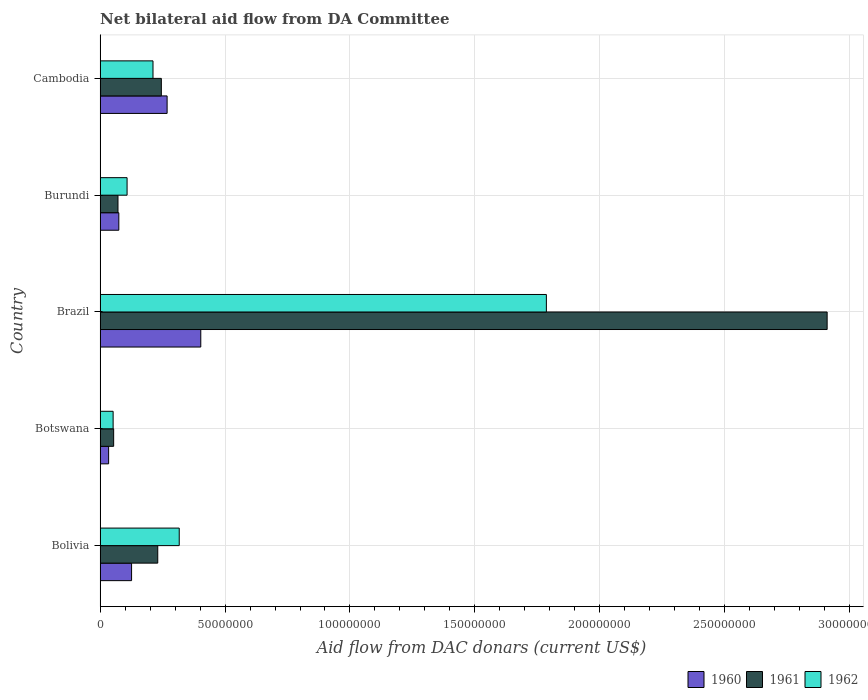How many different coloured bars are there?
Your response must be concise. 3. How many groups of bars are there?
Make the answer very short. 5. Are the number of bars per tick equal to the number of legend labels?
Keep it short and to the point. Yes. How many bars are there on the 4th tick from the top?
Offer a very short reply. 3. How many bars are there on the 5th tick from the bottom?
Your answer should be compact. 3. What is the aid flow in in 1962 in Botswana?
Ensure brevity in your answer.  5.23e+06. Across all countries, what is the maximum aid flow in in 1960?
Your answer should be compact. 4.03e+07. Across all countries, what is the minimum aid flow in in 1962?
Offer a terse response. 5.23e+06. In which country was the aid flow in in 1961 maximum?
Offer a very short reply. Brazil. In which country was the aid flow in in 1961 minimum?
Give a very brief answer. Botswana. What is the total aid flow in in 1962 in the graph?
Offer a terse response. 2.47e+08. What is the difference between the aid flow in in 1962 in Bolivia and that in Cambodia?
Offer a very short reply. 1.05e+07. What is the difference between the aid flow in in 1960 in Bolivia and the aid flow in in 1962 in Cambodia?
Your answer should be very brief. -8.57e+06. What is the average aid flow in in 1960 per country?
Give a very brief answer. 1.81e+07. What is the difference between the aid flow in in 1962 and aid flow in in 1960 in Botswana?
Provide a succinct answer. 1.80e+06. In how many countries, is the aid flow in in 1961 greater than 50000000 US$?
Keep it short and to the point. 1. What is the ratio of the aid flow in in 1961 in Bolivia to that in Cambodia?
Offer a very short reply. 0.94. Is the aid flow in in 1962 in Botswana less than that in Brazil?
Ensure brevity in your answer.  Yes. Is the difference between the aid flow in in 1962 in Botswana and Cambodia greater than the difference between the aid flow in in 1960 in Botswana and Cambodia?
Offer a terse response. Yes. What is the difference between the highest and the second highest aid flow in in 1961?
Your answer should be very brief. 2.66e+08. What is the difference between the highest and the lowest aid flow in in 1960?
Provide a succinct answer. 3.69e+07. In how many countries, is the aid flow in in 1962 greater than the average aid flow in in 1962 taken over all countries?
Your answer should be very brief. 1. How many bars are there?
Your response must be concise. 15. Are all the bars in the graph horizontal?
Offer a very short reply. Yes. How many countries are there in the graph?
Your answer should be very brief. 5. Are the values on the major ticks of X-axis written in scientific E-notation?
Provide a short and direct response. No. Does the graph contain any zero values?
Your answer should be very brief. No. How many legend labels are there?
Provide a succinct answer. 3. What is the title of the graph?
Give a very brief answer. Net bilateral aid flow from DA Committee. What is the label or title of the X-axis?
Provide a succinct answer. Aid flow from DAC donars (current US$). What is the Aid flow from DAC donars (current US$) in 1960 in Bolivia?
Your answer should be very brief. 1.26e+07. What is the Aid flow from DAC donars (current US$) of 1961 in Bolivia?
Give a very brief answer. 2.31e+07. What is the Aid flow from DAC donars (current US$) of 1962 in Bolivia?
Provide a succinct answer. 3.17e+07. What is the Aid flow from DAC donars (current US$) in 1960 in Botswana?
Ensure brevity in your answer.  3.43e+06. What is the Aid flow from DAC donars (current US$) of 1961 in Botswana?
Make the answer very short. 5.44e+06. What is the Aid flow from DAC donars (current US$) of 1962 in Botswana?
Your answer should be compact. 5.23e+06. What is the Aid flow from DAC donars (current US$) of 1960 in Brazil?
Offer a very short reply. 4.03e+07. What is the Aid flow from DAC donars (current US$) in 1961 in Brazil?
Offer a terse response. 2.91e+08. What is the Aid flow from DAC donars (current US$) of 1962 in Brazil?
Your response must be concise. 1.79e+08. What is the Aid flow from DAC donars (current US$) in 1960 in Burundi?
Make the answer very short. 7.51e+06. What is the Aid flow from DAC donars (current US$) of 1961 in Burundi?
Ensure brevity in your answer.  7.17e+06. What is the Aid flow from DAC donars (current US$) of 1962 in Burundi?
Your answer should be very brief. 1.08e+07. What is the Aid flow from DAC donars (current US$) in 1960 in Cambodia?
Give a very brief answer. 2.68e+07. What is the Aid flow from DAC donars (current US$) in 1961 in Cambodia?
Offer a terse response. 2.45e+07. What is the Aid flow from DAC donars (current US$) of 1962 in Cambodia?
Give a very brief answer. 2.12e+07. Across all countries, what is the maximum Aid flow from DAC donars (current US$) in 1960?
Give a very brief answer. 4.03e+07. Across all countries, what is the maximum Aid flow from DAC donars (current US$) in 1961?
Ensure brevity in your answer.  2.91e+08. Across all countries, what is the maximum Aid flow from DAC donars (current US$) of 1962?
Offer a terse response. 1.79e+08. Across all countries, what is the minimum Aid flow from DAC donars (current US$) of 1960?
Your answer should be very brief. 3.43e+06. Across all countries, what is the minimum Aid flow from DAC donars (current US$) in 1961?
Provide a succinct answer. 5.44e+06. Across all countries, what is the minimum Aid flow from DAC donars (current US$) in 1962?
Your answer should be compact. 5.23e+06. What is the total Aid flow from DAC donars (current US$) of 1960 in the graph?
Ensure brevity in your answer.  9.07e+07. What is the total Aid flow from DAC donars (current US$) in 1961 in the graph?
Provide a succinct answer. 3.51e+08. What is the total Aid flow from DAC donars (current US$) of 1962 in the graph?
Provide a succinct answer. 2.47e+08. What is the difference between the Aid flow from DAC donars (current US$) in 1960 in Bolivia and that in Botswana?
Ensure brevity in your answer.  9.18e+06. What is the difference between the Aid flow from DAC donars (current US$) of 1961 in Bolivia and that in Botswana?
Make the answer very short. 1.76e+07. What is the difference between the Aid flow from DAC donars (current US$) in 1962 in Bolivia and that in Botswana?
Offer a very short reply. 2.64e+07. What is the difference between the Aid flow from DAC donars (current US$) of 1960 in Bolivia and that in Brazil?
Give a very brief answer. -2.77e+07. What is the difference between the Aid flow from DAC donars (current US$) in 1961 in Bolivia and that in Brazil?
Provide a succinct answer. -2.68e+08. What is the difference between the Aid flow from DAC donars (current US$) in 1962 in Bolivia and that in Brazil?
Offer a very short reply. -1.47e+08. What is the difference between the Aid flow from DAC donars (current US$) in 1960 in Bolivia and that in Burundi?
Keep it short and to the point. 5.10e+06. What is the difference between the Aid flow from DAC donars (current US$) of 1961 in Bolivia and that in Burundi?
Offer a very short reply. 1.59e+07. What is the difference between the Aid flow from DAC donars (current US$) of 1962 in Bolivia and that in Burundi?
Your answer should be compact. 2.09e+07. What is the difference between the Aid flow from DAC donars (current US$) in 1960 in Bolivia and that in Cambodia?
Your response must be concise. -1.42e+07. What is the difference between the Aid flow from DAC donars (current US$) of 1961 in Bolivia and that in Cambodia?
Keep it short and to the point. -1.44e+06. What is the difference between the Aid flow from DAC donars (current US$) in 1962 in Bolivia and that in Cambodia?
Keep it short and to the point. 1.05e+07. What is the difference between the Aid flow from DAC donars (current US$) in 1960 in Botswana and that in Brazil?
Your answer should be very brief. -3.69e+07. What is the difference between the Aid flow from DAC donars (current US$) of 1961 in Botswana and that in Brazil?
Offer a terse response. -2.85e+08. What is the difference between the Aid flow from DAC donars (current US$) of 1962 in Botswana and that in Brazil?
Offer a very short reply. -1.73e+08. What is the difference between the Aid flow from DAC donars (current US$) in 1960 in Botswana and that in Burundi?
Make the answer very short. -4.08e+06. What is the difference between the Aid flow from DAC donars (current US$) of 1961 in Botswana and that in Burundi?
Offer a terse response. -1.73e+06. What is the difference between the Aid flow from DAC donars (current US$) of 1962 in Botswana and that in Burundi?
Make the answer very short. -5.58e+06. What is the difference between the Aid flow from DAC donars (current US$) in 1960 in Botswana and that in Cambodia?
Your response must be concise. -2.34e+07. What is the difference between the Aid flow from DAC donars (current US$) of 1961 in Botswana and that in Cambodia?
Offer a terse response. -1.91e+07. What is the difference between the Aid flow from DAC donars (current US$) in 1962 in Botswana and that in Cambodia?
Provide a short and direct response. -1.60e+07. What is the difference between the Aid flow from DAC donars (current US$) of 1960 in Brazil and that in Burundi?
Make the answer very short. 3.28e+07. What is the difference between the Aid flow from DAC donars (current US$) in 1961 in Brazil and that in Burundi?
Give a very brief answer. 2.84e+08. What is the difference between the Aid flow from DAC donars (current US$) in 1962 in Brazil and that in Burundi?
Your response must be concise. 1.68e+08. What is the difference between the Aid flow from DAC donars (current US$) in 1960 in Brazil and that in Cambodia?
Give a very brief answer. 1.35e+07. What is the difference between the Aid flow from DAC donars (current US$) in 1961 in Brazil and that in Cambodia?
Provide a succinct answer. 2.66e+08. What is the difference between the Aid flow from DAC donars (current US$) in 1962 in Brazil and that in Cambodia?
Make the answer very short. 1.57e+08. What is the difference between the Aid flow from DAC donars (current US$) of 1960 in Burundi and that in Cambodia?
Offer a terse response. -1.93e+07. What is the difference between the Aid flow from DAC donars (current US$) of 1961 in Burundi and that in Cambodia?
Keep it short and to the point. -1.74e+07. What is the difference between the Aid flow from DAC donars (current US$) in 1962 in Burundi and that in Cambodia?
Your answer should be very brief. -1.04e+07. What is the difference between the Aid flow from DAC donars (current US$) of 1960 in Bolivia and the Aid flow from DAC donars (current US$) of 1961 in Botswana?
Keep it short and to the point. 7.17e+06. What is the difference between the Aid flow from DAC donars (current US$) in 1960 in Bolivia and the Aid flow from DAC donars (current US$) in 1962 in Botswana?
Your response must be concise. 7.38e+06. What is the difference between the Aid flow from DAC donars (current US$) in 1961 in Bolivia and the Aid flow from DAC donars (current US$) in 1962 in Botswana?
Ensure brevity in your answer.  1.78e+07. What is the difference between the Aid flow from DAC donars (current US$) of 1960 in Bolivia and the Aid flow from DAC donars (current US$) of 1961 in Brazil?
Make the answer very short. -2.78e+08. What is the difference between the Aid flow from DAC donars (current US$) in 1960 in Bolivia and the Aid flow from DAC donars (current US$) in 1962 in Brazil?
Give a very brief answer. -1.66e+08. What is the difference between the Aid flow from DAC donars (current US$) of 1961 in Bolivia and the Aid flow from DAC donars (current US$) of 1962 in Brazil?
Provide a short and direct response. -1.56e+08. What is the difference between the Aid flow from DAC donars (current US$) of 1960 in Bolivia and the Aid flow from DAC donars (current US$) of 1961 in Burundi?
Ensure brevity in your answer.  5.44e+06. What is the difference between the Aid flow from DAC donars (current US$) in 1960 in Bolivia and the Aid flow from DAC donars (current US$) in 1962 in Burundi?
Keep it short and to the point. 1.80e+06. What is the difference between the Aid flow from DAC donars (current US$) in 1961 in Bolivia and the Aid flow from DAC donars (current US$) in 1962 in Burundi?
Give a very brief answer. 1.23e+07. What is the difference between the Aid flow from DAC donars (current US$) of 1960 in Bolivia and the Aid flow from DAC donars (current US$) of 1961 in Cambodia?
Give a very brief answer. -1.19e+07. What is the difference between the Aid flow from DAC donars (current US$) in 1960 in Bolivia and the Aid flow from DAC donars (current US$) in 1962 in Cambodia?
Your response must be concise. -8.57e+06. What is the difference between the Aid flow from DAC donars (current US$) of 1961 in Bolivia and the Aid flow from DAC donars (current US$) of 1962 in Cambodia?
Your answer should be compact. 1.90e+06. What is the difference between the Aid flow from DAC donars (current US$) in 1960 in Botswana and the Aid flow from DAC donars (current US$) in 1961 in Brazil?
Offer a terse response. -2.87e+08. What is the difference between the Aid flow from DAC donars (current US$) of 1960 in Botswana and the Aid flow from DAC donars (current US$) of 1962 in Brazil?
Provide a short and direct response. -1.75e+08. What is the difference between the Aid flow from DAC donars (current US$) of 1961 in Botswana and the Aid flow from DAC donars (current US$) of 1962 in Brazil?
Provide a succinct answer. -1.73e+08. What is the difference between the Aid flow from DAC donars (current US$) in 1960 in Botswana and the Aid flow from DAC donars (current US$) in 1961 in Burundi?
Ensure brevity in your answer.  -3.74e+06. What is the difference between the Aid flow from DAC donars (current US$) in 1960 in Botswana and the Aid flow from DAC donars (current US$) in 1962 in Burundi?
Provide a succinct answer. -7.38e+06. What is the difference between the Aid flow from DAC donars (current US$) of 1961 in Botswana and the Aid flow from DAC donars (current US$) of 1962 in Burundi?
Your response must be concise. -5.37e+06. What is the difference between the Aid flow from DAC donars (current US$) of 1960 in Botswana and the Aid flow from DAC donars (current US$) of 1961 in Cambodia?
Keep it short and to the point. -2.11e+07. What is the difference between the Aid flow from DAC donars (current US$) in 1960 in Botswana and the Aid flow from DAC donars (current US$) in 1962 in Cambodia?
Make the answer very short. -1.78e+07. What is the difference between the Aid flow from DAC donars (current US$) in 1961 in Botswana and the Aid flow from DAC donars (current US$) in 1962 in Cambodia?
Provide a short and direct response. -1.57e+07. What is the difference between the Aid flow from DAC donars (current US$) of 1960 in Brazil and the Aid flow from DAC donars (current US$) of 1961 in Burundi?
Your response must be concise. 3.31e+07. What is the difference between the Aid flow from DAC donars (current US$) of 1960 in Brazil and the Aid flow from DAC donars (current US$) of 1962 in Burundi?
Your answer should be compact. 2.95e+07. What is the difference between the Aid flow from DAC donars (current US$) in 1961 in Brazil and the Aid flow from DAC donars (current US$) in 1962 in Burundi?
Offer a very short reply. 2.80e+08. What is the difference between the Aid flow from DAC donars (current US$) of 1960 in Brazil and the Aid flow from DAC donars (current US$) of 1961 in Cambodia?
Ensure brevity in your answer.  1.58e+07. What is the difference between the Aid flow from DAC donars (current US$) of 1960 in Brazil and the Aid flow from DAC donars (current US$) of 1962 in Cambodia?
Keep it short and to the point. 1.91e+07. What is the difference between the Aid flow from DAC donars (current US$) in 1961 in Brazil and the Aid flow from DAC donars (current US$) in 1962 in Cambodia?
Your answer should be very brief. 2.70e+08. What is the difference between the Aid flow from DAC donars (current US$) in 1960 in Burundi and the Aid flow from DAC donars (current US$) in 1961 in Cambodia?
Your response must be concise. -1.70e+07. What is the difference between the Aid flow from DAC donars (current US$) in 1960 in Burundi and the Aid flow from DAC donars (current US$) in 1962 in Cambodia?
Offer a terse response. -1.37e+07. What is the difference between the Aid flow from DAC donars (current US$) in 1961 in Burundi and the Aid flow from DAC donars (current US$) in 1962 in Cambodia?
Provide a short and direct response. -1.40e+07. What is the average Aid flow from DAC donars (current US$) in 1960 per country?
Offer a very short reply. 1.81e+07. What is the average Aid flow from DAC donars (current US$) of 1961 per country?
Provide a short and direct response. 7.02e+07. What is the average Aid flow from DAC donars (current US$) of 1962 per country?
Ensure brevity in your answer.  4.95e+07. What is the difference between the Aid flow from DAC donars (current US$) in 1960 and Aid flow from DAC donars (current US$) in 1961 in Bolivia?
Offer a very short reply. -1.05e+07. What is the difference between the Aid flow from DAC donars (current US$) of 1960 and Aid flow from DAC donars (current US$) of 1962 in Bolivia?
Your response must be concise. -1.91e+07. What is the difference between the Aid flow from DAC donars (current US$) of 1961 and Aid flow from DAC donars (current US$) of 1962 in Bolivia?
Your answer should be compact. -8.60e+06. What is the difference between the Aid flow from DAC donars (current US$) in 1960 and Aid flow from DAC donars (current US$) in 1961 in Botswana?
Ensure brevity in your answer.  -2.01e+06. What is the difference between the Aid flow from DAC donars (current US$) in 1960 and Aid flow from DAC donars (current US$) in 1962 in Botswana?
Your answer should be compact. -1.80e+06. What is the difference between the Aid flow from DAC donars (current US$) in 1960 and Aid flow from DAC donars (current US$) in 1961 in Brazil?
Your answer should be very brief. -2.51e+08. What is the difference between the Aid flow from DAC donars (current US$) of 1960 and Aid flow from DAC donars (current US$) of 1962 in Brazil?
Make the answer very short. -1.38e+08. What is the difference between the Aid flow from DAC donars (current US$) in 1961 and Aid flow from DAC donars (current US$) in 1962 in Brazil?
Offer a terse response. 1.12e+08. What is the difference between the Aid flow from DAC donars (current US$) of 1960 and Aid flow from DAC donars (current US$) of 1961 in Burundi?
Your answer should be compact. 3.40e+05. What is the difference between the Aid flow from DAC donars (current US$) of 1960 and Aid flow from DAC donars (current US$) of 1962 in Burundi?
Provide a succinct answer. -3.30e+06. What is the difference between the Aid flow from DAC donars (current US$) in 1961 and Aid flow from DAC donars (current US$) in 1962 in Burundi?
Provide a succinct answer. -3.64e+06. What is the difference between the Aid flow from DAC donars (current US$) in 1960 and Aid flow from DAC donars (current US$) in 1961 in Cambodia?
Offer a terse response. 2.31e+06. What is the difference between the Aid flow from DAC donars (current US$) in 1960 and Aid flow from DAC donars (current US$) in 1962 in Cambodia?
Offer a terse response. 5.65e+06. What is the difference between the Aid flow from DAC donars (current US$) in 1961 and Aid flow from DAC donars (current US$) in 1962 in Cambodia?
Ensure brevity in your answer.  3.34e+06. What is the ratio of the Aid flow from DAC donars (current US$) of 1960 in Bolivia to that in Botswana?
Keep it short and to the point. 3.68. What is the ratio of the Aid flow from DAC donars (current US$) in 1961 in Bolivia to that in Botswana?
Make the answer very short. 4.24. What is the ratio of the Aid flow from DAC donars (current US$) of 1962 in Bolivia to that in Botswana?
Offer a very short reply. 6.06. What is the ratio of the Aid flow from DAC donars (current US$) in 1960 in Bolivia to that in Brazil?
Your answer should be very brief. 0.31. What is the ratio of the Aid flow from DAC donars (current US$) of 1961 in Bolivia to that in Brazil?
Your response must be concise. 0.08. What is the ratio of the Aid flow from DAC donars (current US$) of 1962 in Bolivia to that in Brazil?
Offer a terse response. 0.18. What is the ratio of the Aid flow from DAC donars (current US$) in 1960 in Bolivia to that in Burundi?
Offer a very short reply. 1.68. What is the ratio of the Aid flow from DAC donars (current US$) of 1961 in Bolivia to that in Burundi?
Your answer should be compact. 3.22. What is the ratio of the Aid flow from DAC donars (current US$) in 1962 in Bolivia to that in Burundi?
Your response must be concise. 2.93. What is the ratio of the Aid flow from DAC donars (current US$) of 1960 in Bolivia to that in Cambodia?
Offer a very short reply. 0.47. What is the ratio of the Aid flow from DAC donars (current US$) in 1961 in Bolivia to that in Cambodia?
Your answer should be compact. 0.94. What is the ratio of the Aid flow from DAC donars (current US$) in 1962 in Bolivia to that in Cambodia?
Make the answer very short. 1.5. What is the ratio of the Aid flow from DAC donars (current US$) in 1960 in Botswana to that in Brazil?
Provide a succinct answer. 0.09. What is the ratio of the Aid flow from DAC donars (current US$) of 1961 in Botswana to that in Brazil?
Your answer should be compact. 0.02. What is the ratio of the Aid flow from DAC donars (current US$) in 1962 in Botswana to that in Brazil?
Offer a very short reply. 0.03. What is the ratio of the Aid flow from DAC donars (current US$) in 1960 in Botswana to that in Burundi?
Your answer should be very brief. 0.46. What is the ratio of the Aid flow from DAC donars (current US$) in 1961 in Botswana to that in Burundi?
Provide a short and direct response. 0.76. What is the ratio of the Aid flow from DAC donars (current US$) in 1962 in Botswana to that in Burundi?
Keep it short and to the point. 0.48. What is the ratio of the Aid flow from DAC donars (current US$) of 1960 in Botswana to that in Cambodia?
Offer a terse response. 0.13. What is the ratio of the Aid flow from DAC donars (current US$) in 1961 in Botswana to that in Cambodia?
Offer a terse response. 0.22. What is the ratio of the Aid flow from DAC donars (current US$) in 1962 in Botswana to that in Cambodia?
Make the answer very short. 0.25. What is the ratio of the Aid flow from DAC donars (current US$) of 1960 in Brazil to that in Burundi?
Ensure brevity in your answer.  5.37. What is the ratio of the Aid flow from DAC donars (current US$) in 1961 in Brazil to that in Burundi?
Ensure brevity in your answer.  40.57. What is the ratio of the Aid flow from DAC donars (current US$) in 1962 in Brazil to that in Burundi?
Offer a very short reply. 16.52. What is the ratio of the Aid flow from DAC donars (current US$) in 1960 in Brazil to that in Cambodia?
Give a very brief answer. 1.5. What is the ratio of the Aid flow from DAC donars (current US$) of 1961 in Brazil to that in Cambodia?
Make the answer very short. 11.86. What is the ratio of the Aid flow from DAC donars (current US$) of 1962 in Brazil to that in Cambodia?
Provide a short and direct response. 8.43. What is the ratio of the Aid flow from DAC donars (current US$) of 1960 in Burundi to that in Cambodia?
Ensure brevity in your answer.  0.28. What is the ratio of the Aid flow from DAC donars (current US$) in 1961 in Burundi to that in Cambodia?
Your answer should be compact. 0.29. What is the ratio of the Aid flow from DAC donars (current US$) in 1962 in Burundi to that in Cambodia?
Make the answer very short. 0.51. What is the difference between the highest and the second highest Aid flow from DAC donars (current US$) in 1960?
Make the answer very short. 1.35e+07. What is the difference between the highest and the second highest Aid flow from DAC donars (current US$) of 1961?
Your answer should be very brief. 2.66e+08. What is the difference between the highest and the second highest Aid flow from DAC donars (current US$) of 1962?
Provide a short and direct response. 1.47e+08. What is the difference between the highest and the lowest Aid flow from DAC donars (current US$) in 1960?
Your answer should be very brief. 3.69e+07. What is the difference between the highest and the lowest Aid flow from DAC donars (current US$) of 1961?
Your response must be concise. 2.85e+08. What is the difference between the highest and the lowest Aid flow from DAC donars (current US$) of 1962?
Keep it short and to the point. 1.73e+08. 